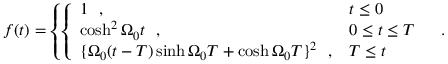Convert formula to latex. <formula><loc_0><loc_0><loc_500><loc_500>f ( t ) = \left \{ \left \{ \begin{array} { l l } { 1 \ \ , } & { t \leq 0 } \\ { { \cosh ^ { 2 } \Omega _ { 0 } t \ \ , } } & { 0 \leq t \leq T } \\ { { \{ \Omega _ { 0 } ( t - T ) \sinh \Omega _ { 0 } T + \cosh \Omega _ { 0 } T \} ^ { 2 } \ \ , } } & { T \leq t } \end{array} \ \ .</formula> 